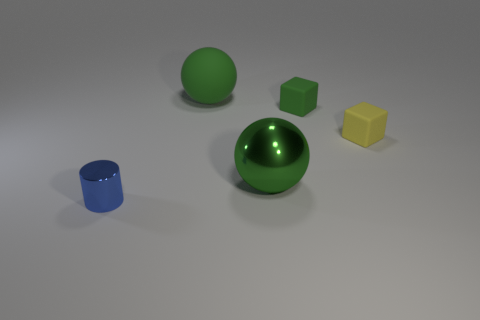Add 2 yellow cubes. How many objects exist? 7 Subtract all green cubes. How many cubes are left? 1 Subtract all cylinders. How many objects are left? 4 Subtract 1 balls. How many balls are left? 1 Subtract all brown spheres. Subtract all red cubes. How many spheres are left? 2 Subtract all cyan cylinders. How many green blocks are left? 1 Subtract all small rubber objects. Subtract all metal balls. How many objects are left? 2 Add 2 green metallic objects. How many green metallic objects are left? 3 Add 4 tiny green cubes. How many tiny green cubes exist? 5 Subtract 0 purple blocks. How many objects are left? 5 